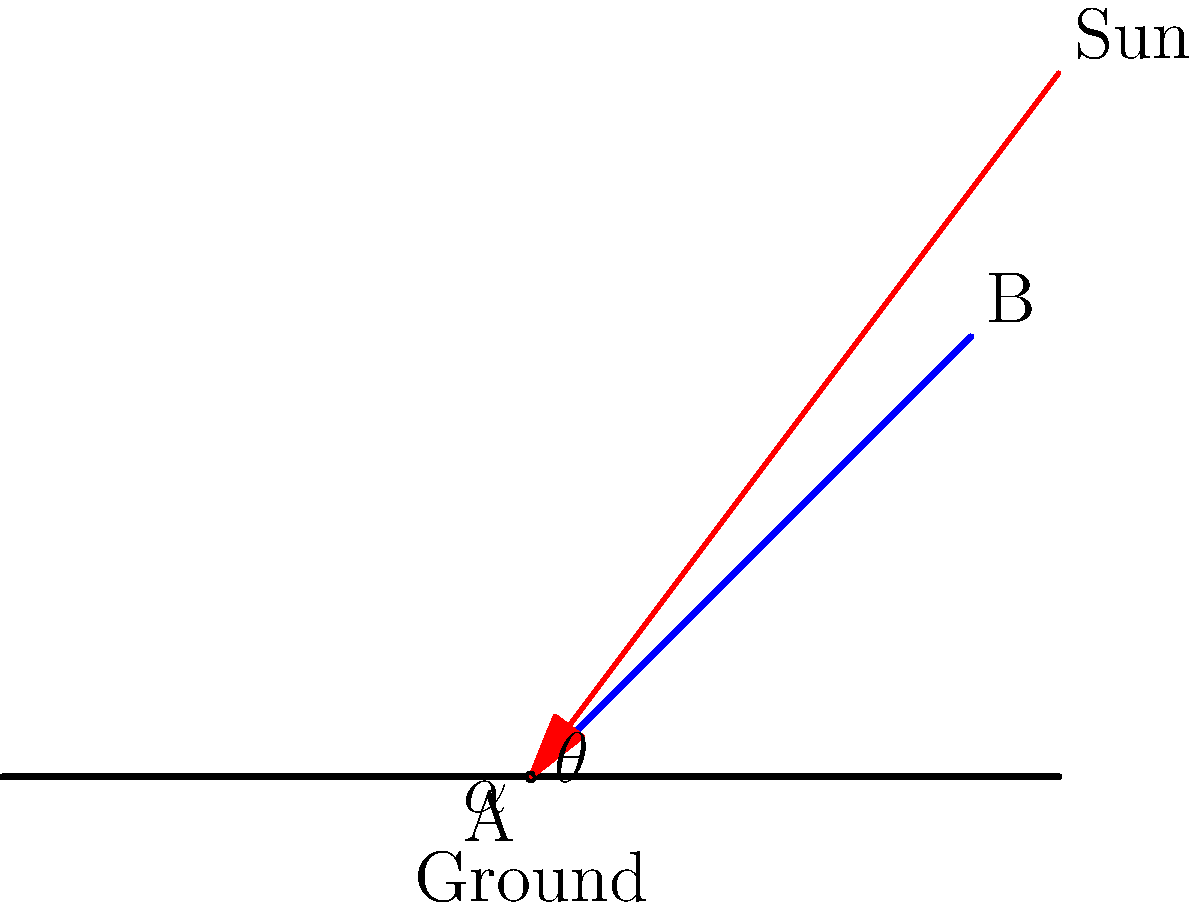A solar panel is mounted at point A on the ground and extends to point B. The angle between the ground and the panel is $\theta$. The sun's rays hit the ground at an angle $\alpha = 60°$ from the horizontal. At what angle $\theta$ should the solar panel be positioned to maximize energy collection, assuming optimal collection occurs when the panel is perpendicular to the sun's rays? To maximize energy collection, the solar panel should be perpendicular to the sun's rays. This means we need to find the angle $\theta$ that makes the panel perpendicular to the incoming sunlight.

Step 1: Recognize that when the panel is perpendicular to the sun's rays, it forms a right angle (90°) with the ray.

Step 2: The sum of angles in a triangle is 180°. In the triangle formed by the sun ray, the ground, and the solar panel, we have:
$$\alpha + 90° + (90° - \theta) = 180°$$

Step 3: Substitute the known value of $\alpha = 60°$:
$$60° + 90° + (90° - \theta) = 180°$$

Step 4: Simplify:
$$240° - \theta = 180°$$

Step 5: Solve for $\theta$:
$$-\theta = 180° - 240°$$
$$-\theta = -60°$$
$$\theta = 60°$$

Therefore, the optimal angle for the solar panel is 60° from the horizontal, which is the same as the sun's angle from the horizontal. This makes sense geometrically, as it places the panel perpendicular to the incoming sunlight.
Answer: $60°$ 